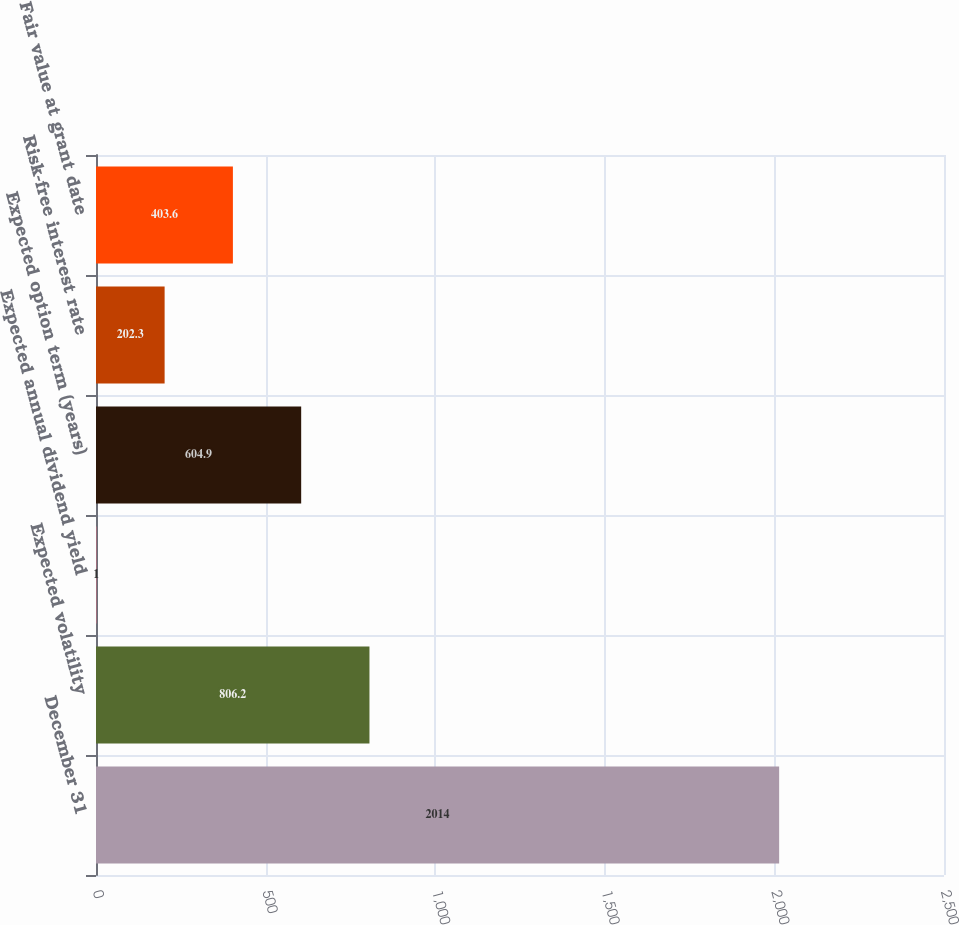Convert chart to OTSL. <chart><loc_0><loc_0><loc_500><loc_500><bar_chart><fcel>December 31<fcel>Expected volatility<fcel>Expected annual dividend yield<fcel>Expected option term (years)<fcel>Risk-free interest rate<fcel>Fair value at grant date<nl><fcel>2014<fcel>806.2<fcel>1<fcel>604.9<fcel>202.3<fcel>403.6<nl></chart> 